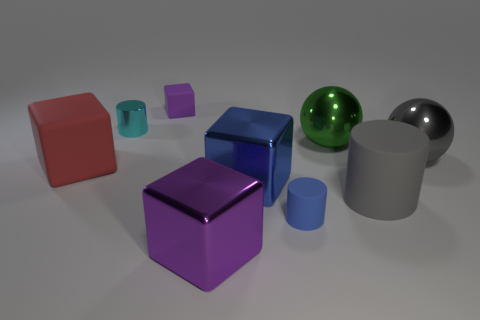Subtract all red blocks. How many blocks are left? 3 Subtract all purple rubber cubes. How many cubes are left? 3 Subtract 2 blocks. How many blocks are left? 2 Subtract all brown cubes. Subtract all gray cylinders. How many cubes are left? 4 Subtract all cylinders. How many objects are left? 6 Add 4 tiny matte things. How many tiny matte things exist? 6 Subtract 0 brown cylinders. How many objects are left? 9 Subtract all red things. Subtract all small purple cubes. How many objects are left? 7 Add 9 small blue matte cylinders. How many small blue matte cylinders are left? 10 